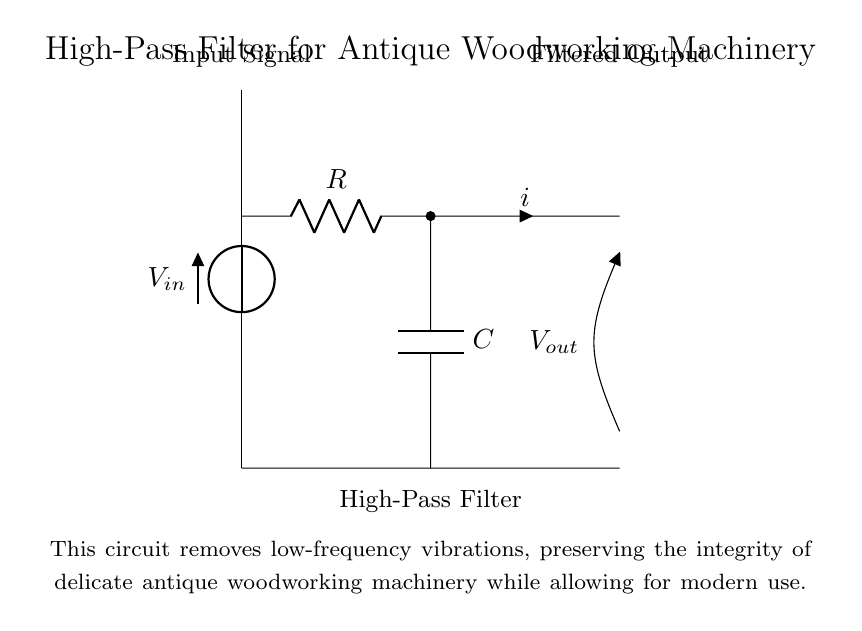What is the input voltage represented as in the circuit? The input voltage in the circuit is denoted by the symbol V with a subscript "in". This indicates the voltage entering the circuit before any filtering occurs.
Answer: V in What components make up the high-pass filter? The high-pass filter consists of a resistor (R) and a capacitor (C), which are essential for its filtering action. The configuration allows high frequencies to pass while attenuating lower frequencies.
Answer: R and C What is the purpose of the high-pass filter in this circuit? The purpose of the high-pass filter is to remove low-frequency vibrations from the input signal, which is crucial for preserving the functionality and integrity of antique woodworking machinery.
Answer: Remove low-frequency vibrations What does the output voltage represent in this circuit? The output voltage, denoted as V with a subscript "out", represents the voltage level after the filtering process. It shows the resulting signal that has had low frequencies filtered out.
Answer: V out How does the placement of the resistor and capacitor affect the filtering? The arrangement of the resistor in series with the input and the capacitor to ground creates a path for high-frequency signals to pass while blocking lower frequencies. This defines the high-pass functionality of the circuit.
Answer: It creates a high-pass filter What would happen to the antique machinery if low-frequency vibrations are not removed? If low-frequency vibrations are not removed, they could adversely affect the operation and potentially damage the delicate components of the antique woodworking machinery, leading to decreased performance and risk of failure.
Answer: Machinery damage What type of current flows through the circuit? The circuit features an alternating current (AC) since it is designed to filter frequency signals typical of those found in audio or mechanical vibrations.
Answer: Alternating current 